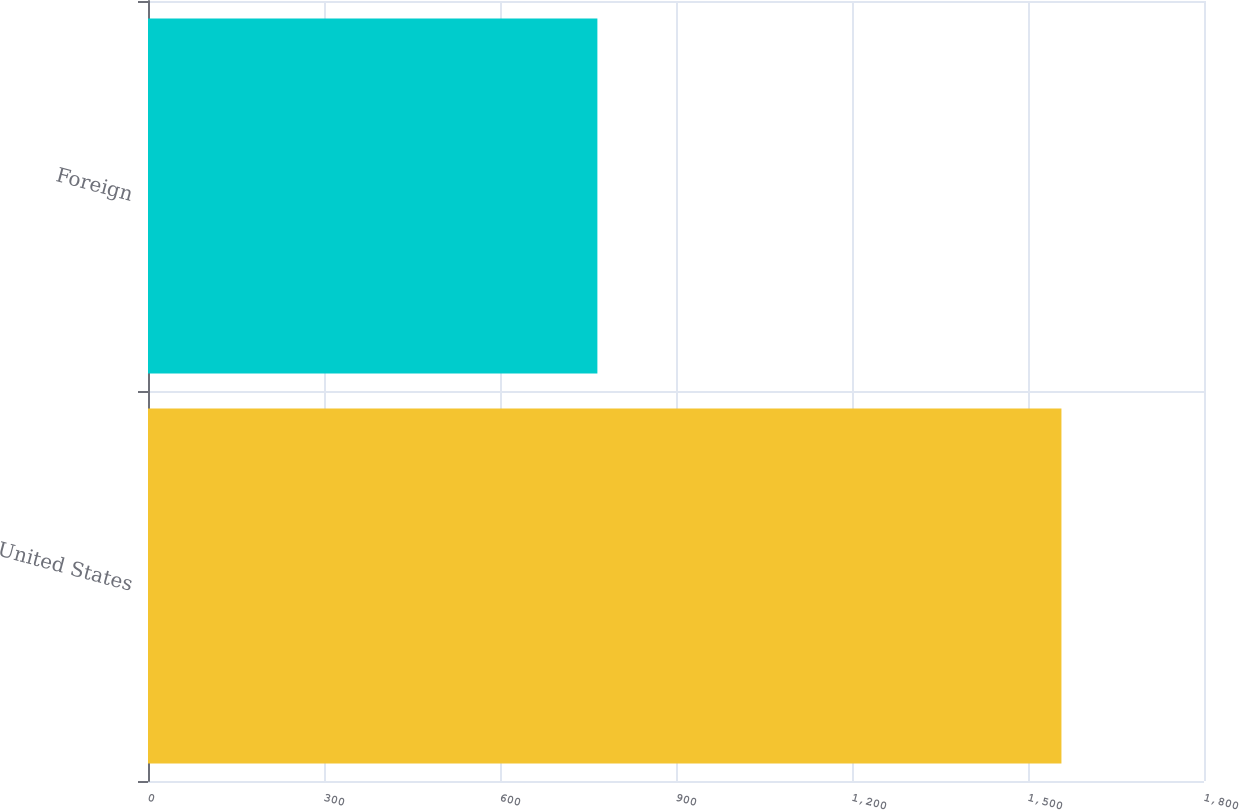Convert chart to OTSL. <chart><loc_0><loc_0><loc_500><loc_500><bar_chart><fcel>United States<fcel>Foreign<nl><fcel>1557<fcel>766<nl></chart> 